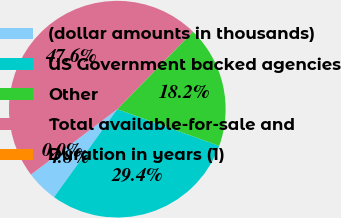Convert chart. <chart><loc_0><loc_0><loc_500><loc_500><pie_chart><fcel>(dollar amounts in thousands)<fcel>US Government backed agencies<fcel>Other<fcel>Total available-for-sale and<fcel>Duration in years (1)<nl><fcel>4.76%<fcel>29.43%<fcel>18.19%<fcel>47.62%<fcel>0.0%<nl></chart> 